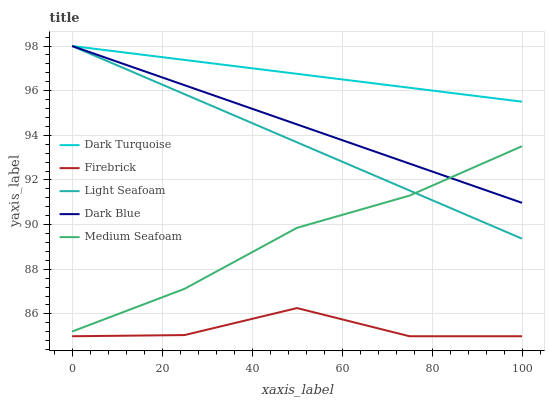Does Firebrick have the minimum area under the curve?
Answer yes or no. Yes. Does Dark Turquoise have the maximum area under the curve?
Answer yes or no. Yes. Does Light Seafoam have the minimum area under the curve?
Answer yes or no. No. Does Light Seafoam have the maximum area under the curve?
Answer yes or no. No. Is Light Seafoam the smoothest?
Answer yes or no. Yes. Is Firebrick the roughest?
Answer yes or no. Yes. Is Firebrick the smoothest?
Answer yes or no. No. Is Light Seafoam the roughest?
Answer yes or no. No. Does Firebrick have the lowest value?
Answer yes or no. Yes. Does Light Seafoam have the lowest value?
Answer yes or no. No. Does Dark Blue have the highest value?
Answer yes or no. Yes. Does Firebrick have the highest value?
Answer yes or no. No. Is Firebrick less than Dark Blue?
Answer yes or no. Yes. Is Light Seafoam greater than Firebrick?
Answer yes or no. Yes. Does Dark Turquoise intersect Light Seafoam?
Answer yes or no. Yes. Is Dark Turquoise less than Light Seafoam?
Answer yes or no. No. Is Dark Turquoise greater than Light Seafoam?
Answer yes or no. No. Does Firebrick intersect Dark Blue?
Answer yes or no. No. 